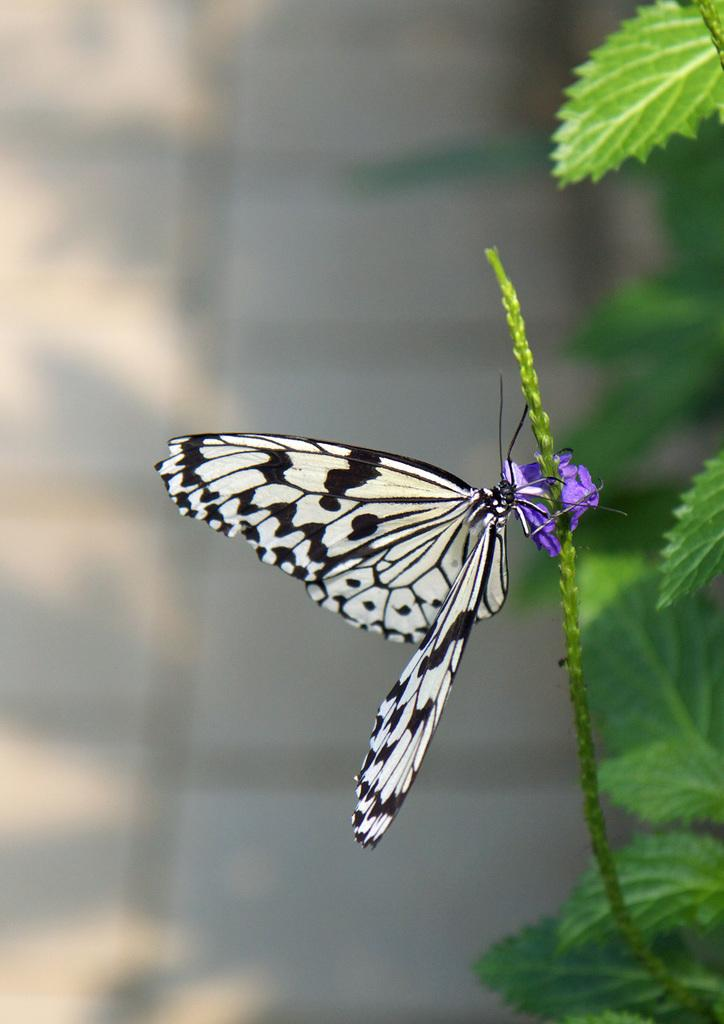What is the main subject of the image? There is a butterfly in the image. What is the butterfly standing on? The butterfly is standing on a purple flower plant. Can you describe the background of the image? The background of the image is blurry. What type of organization can be seen in the image? There is no organization present in the image; it features a butterfly standing on a purple flower plant with a blurry background. 